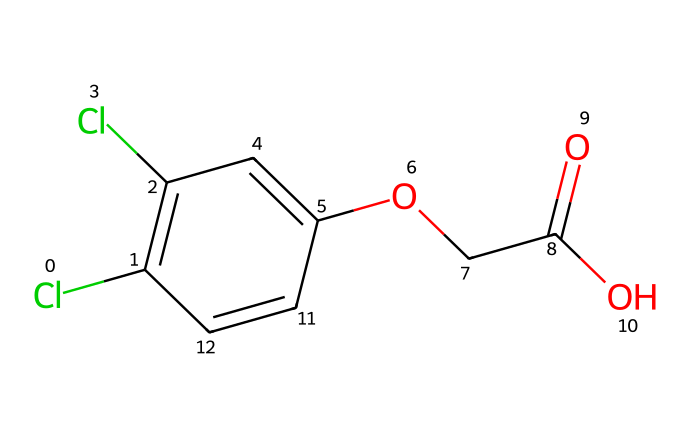What is the common name of this chemical? The chemical structure corresponds to a well-known herbicide commonly referred to as 2,4-Dichlorophenoxyacetic acid, or simply 2,4-D.
Answer: 2,4-D How many chlorine atoms are present in this chemical? By analyzing the structure, we can observe that there are two chlorine atoms indicated by the "Cl" labels in the SMILES representation.
Answer: 2 What functional groups are present in this chemical? The chemical contains a carboxylic acid group (–COOH) and an ether group (-O-) as part of its structure, identifiable from the connectivity in the SMILES.
Answer: carboxylic acid, ether How many carbon atoms are in the structure? Counting the carbon atoms in the structure represented in the SMILES shows that there are a total of 9 carbon atoms present.
Answer: 9 What is the degree of unsaturation of 2,4-D? The degree of unsaturation can be calculated by considering the ring and double bonds in the structure. For 2,4-D, the total degree of unsaturation is 5, due to the presence of the aromatic ring and double bonds.
Answer: 5 What is the significance of the hydroxyl group in this chemical? The hydroxyl (–OH) group plays a crucial role in enhancing the solubility of the molecule in water, impacting its environmental behavior and interaction with biological systems.
Answer: solubility How does the structure of 2,4-D affect its herbicidal properties? The presence of the carboxylic acid group contributes to its ionic nature, while the aromatic ring structure can enhance its ability to penetrate plant tissues, making it effective as a herbicide.
Answer: effective herbicide 